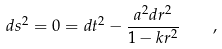Convert formula to latex. <formula><loc_0><loc_0><loc_500><loc_500>d s ^ { 2 } = 0 = d t ^ { 2 } - \frac { a ^ { 2 } d r ^ { 2 } } { 1 - k r ^ { 2 } } \quad ,</formula> 